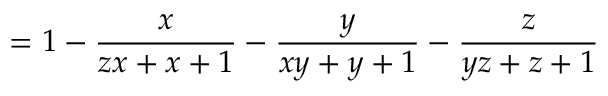Convert formula to latex. <formula><loc_0><loc_0><loc_500><loc_500>= 1 - { \frac { x } { z x + x + 1 } } - { \frac { y } { x y + y + 1 } } - { \frac { z } { y z + z + 1 } }</formula> 